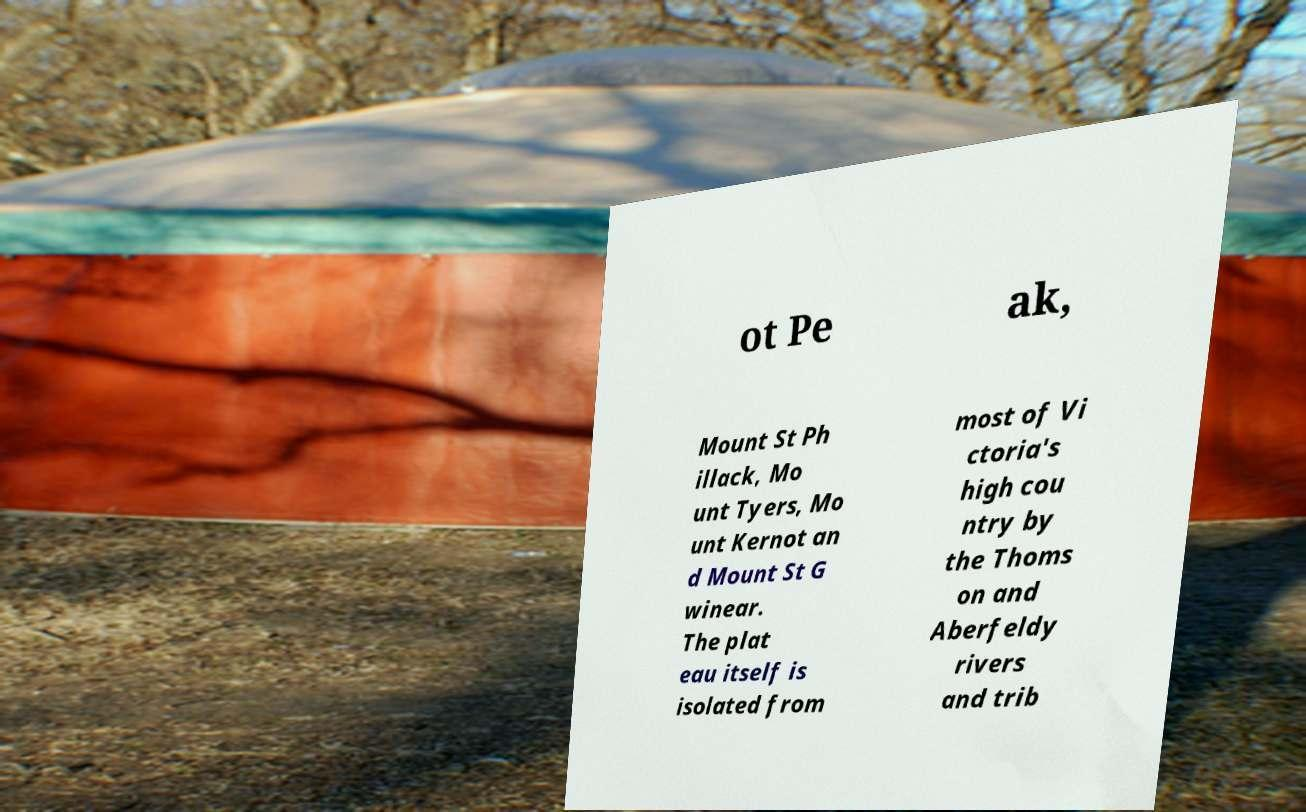Can you read and provide the text displayed in the image?This photo seems to have some interesting text. Can you extract and type it out for me? ot Pe ak, Mount St Ph illack, Mo unt Tyers, Mo unt Kernot an d Mount St G winear. The plat eau itself is isolated from most of Vi ctoria's high cou ntry by the Thoms on and Aberfeldy rivers and trib 